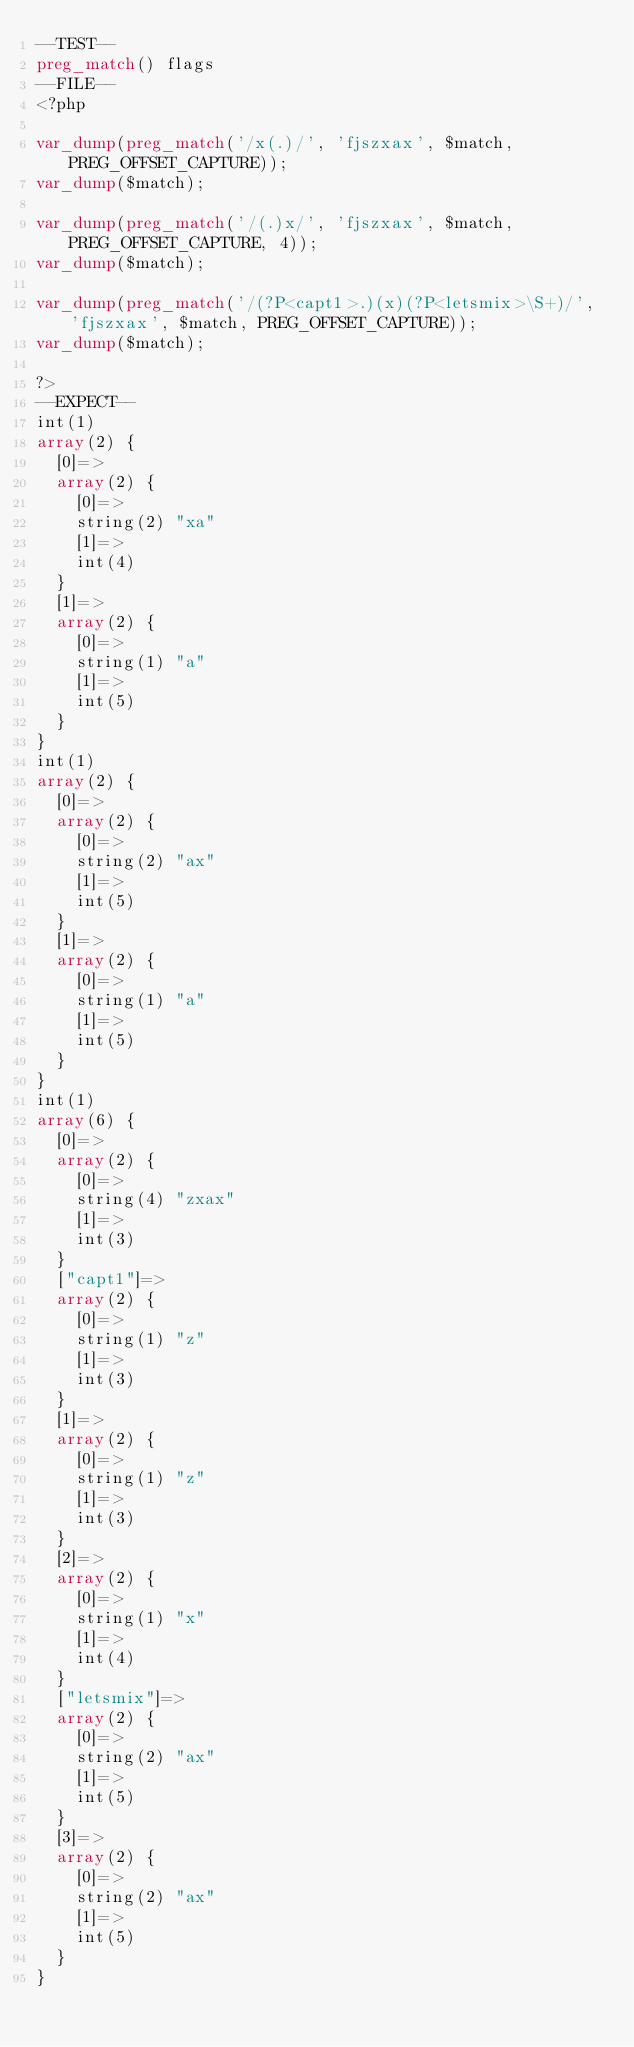<code> <loc_0><loc_0><loc_500><loc_500><_PHP_>--TEST--
preg_match() flags
--FILE--
<?php

var_dump(preg_match('/x(.)/', 'fjszxax', $match, PREG_OFFSET_CAPTURE));
var_dump($match);

var_dump(preg_match('/(.)x/', 'fjszxax', $match, PREG_OFFSET_CAPTURE, 4));
var_dump($match);

var_dump(preg_match('/(?P<capt1>.)(x)(?P<letsmix>\S+)/', 'fjszxax', $match, PREG_OFFSET_CAPTURE));
var_dump($match);

?>
--EXPECT--
int(1)
array(2) {
  [0]=>
  array(2) {
    [0]=>
    string(2) "xa"
    [1]=>
    int(4)
  }
  [1]=>
  array(2) {
    [0]=>
    string(1) "a"
    [1]=>
    int(5)
  }
}
int(1)
array(2) {
  [0]=>
  array(2) {
    [0]=>
    string(2) "ax"
    [1]=>
    int(5)
  }
  [1]=>
  array(2) {
    [0]=>
    string(1) "a"
    [1]=>
    int(5)
  }
}
int(1)
array(6) {
  [0]=>
  array(2) {
    [0]=>
    string(4) "zxax"
    [1]=>
    int(3)
  }
  ["capt1"]=>
  array(2) {
    [0]=>
    string(1) "z"
    [1]=>
    int(3)
  }
  [1]=>
  array(2) {
    [0]=>
    string(1) "z"
    [1]=>
    int(3)
  }
  [2]=>
  array(2) {
    [0]=>
    string(1) "x"
    [1]=>
    int(4)
  }
  ["letsmix"]=>
  array(2) {
    [0]=>
    string(2) "ax"
    [1]=>
    int(5)
  }
  [3]=>
  array(2) {
    [0]=>
    string(2) "ax"
    [1]=>
    int(5)
  }
}
</code> 